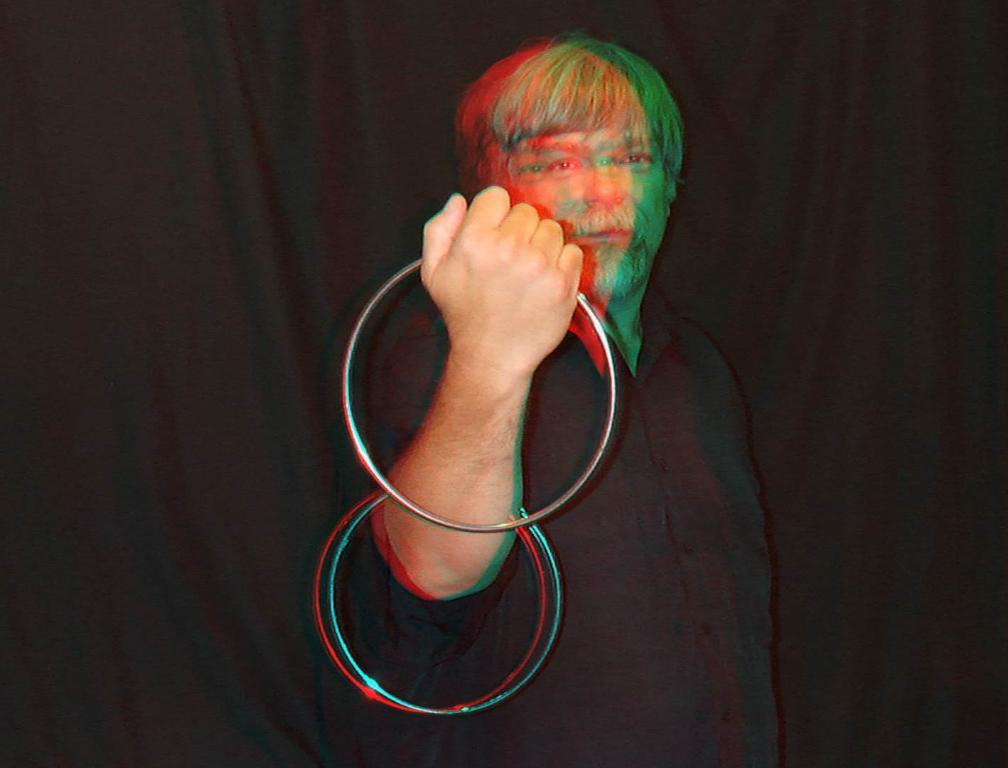What is the main subject of the image? The main subject of the image is a person. What is the person holding in the image? The person is holding metal rings. What can be observed about the background of the image? The background of the image is dark. What type of tooth can be seen in the image? There is no tooth present in the image. How many hands does the woman have in the image? The facts provided do not specify the gender of the person in the image, so we cannot definitively say if the person is a woman or not. Additionally, the number of hands the person has cannot be determined from the image. 